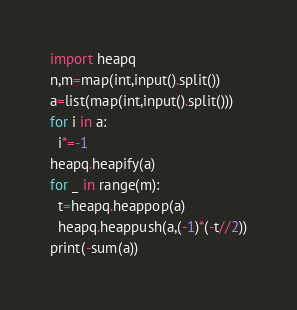Convert code to text. <code><loc_0><loc_0><loc_500><loc_500><_Python_>import heapq
n,m=map(int,input().split())
a=list(map(int,input().split()))
for i in a:
  i*=-1
heapq.heapify(a)
for _ in range(m):
  t=heapq.heappop(a)
  heapq.heappush(a,(-1)*(-t//2))
print(-sum(a))</code> 